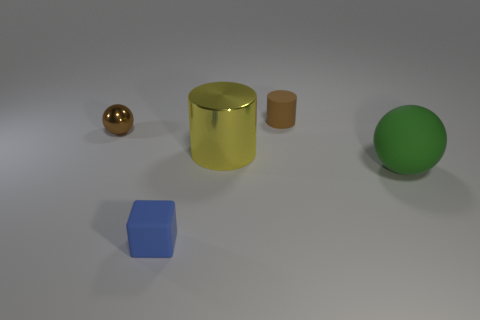Add 2 small cyan shiny objects. How many objects exist? 7 Subtract all spheres. How many objects are left? 3 Subtract 2 spheres. How many spheres are left? 0 Add 1 tiny blue things. How many tiny blue things exist? 2 Subtract 0 red cubes. How many objects are left? 5 Subtract all red cubes. Subtract all red cylinders. How many cubes are left? 1 Subtract all yellow cylinders. How many yellow spheres are left? 0 Subtract all blue cubes. Subtract all green things. How many objects are left? 3 Add 4 brown cylinders. How many brown cylinders are left? 5 